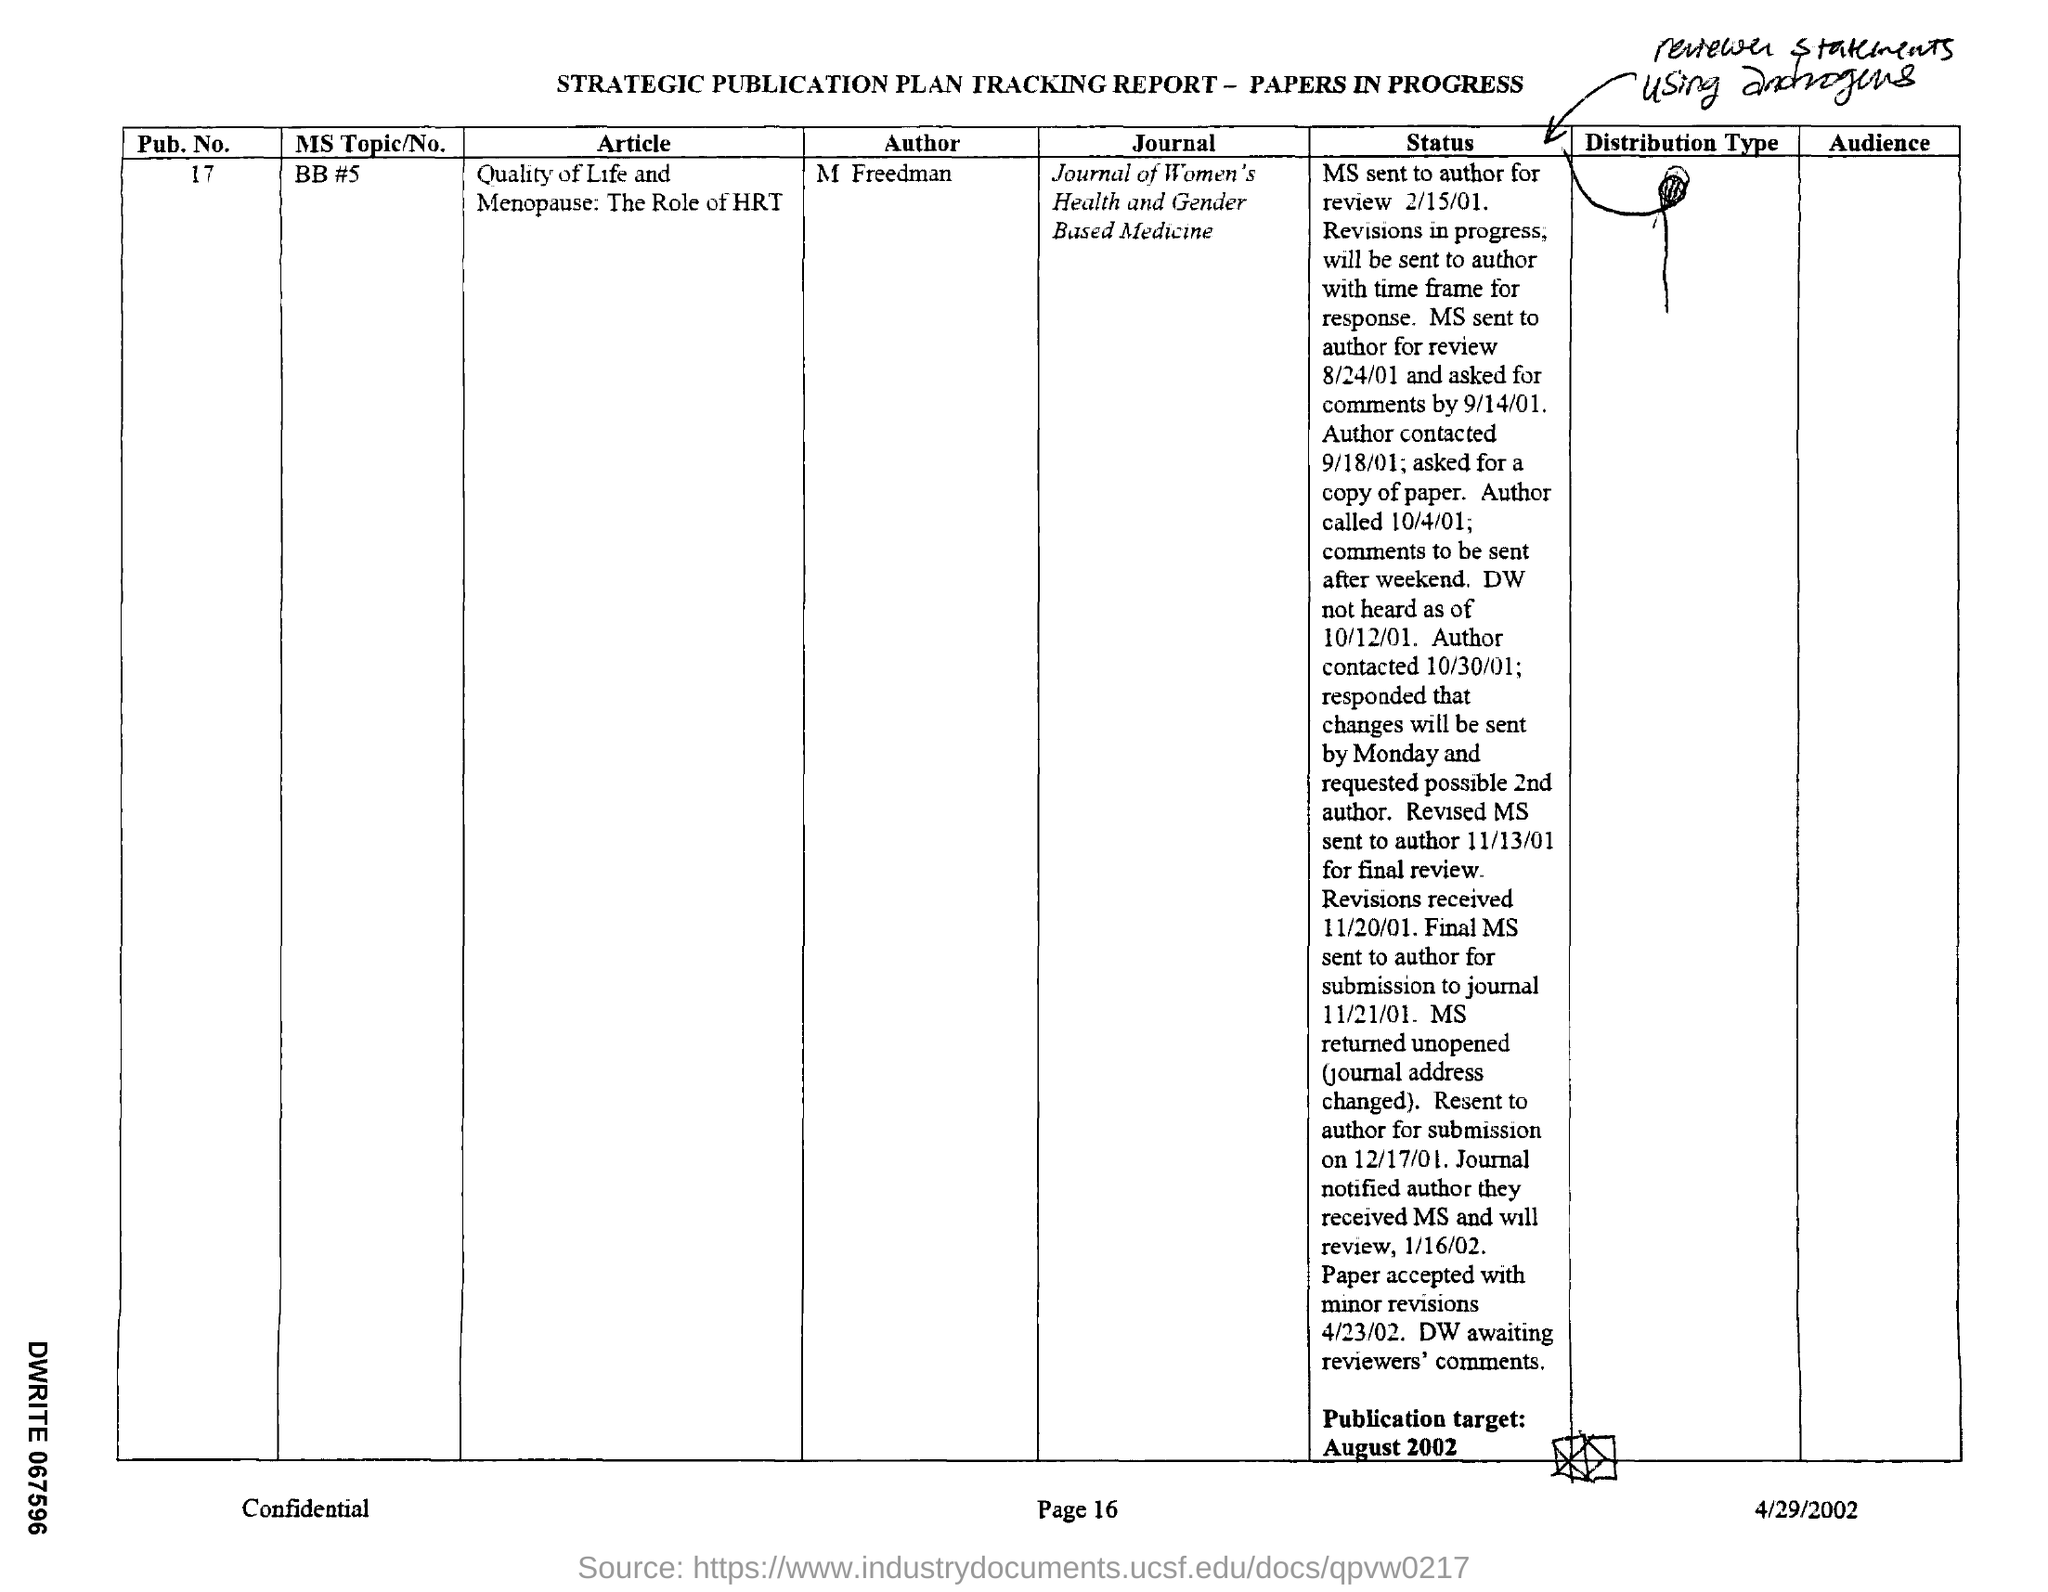Specify some key components in this picture. The author of the article is M FREEDMAN. What is the publication number? The article titled 'Quality of Life and Menopause: The Role of HRT' aims to explore the impact of hormone replacement therapy on the quality of life of menopausal women. The document is dated April 29, 2002. The publication target is August 2002. 